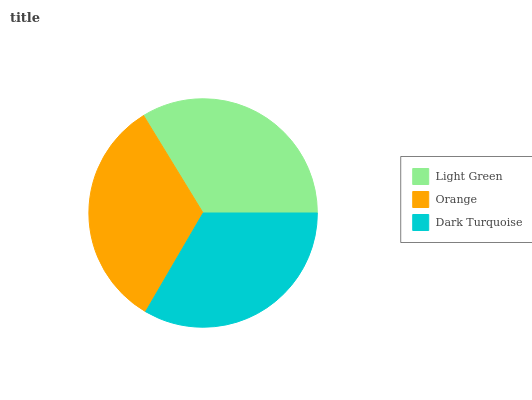Is Orange the minimum?
Answer yes or no. Yes. Is Light Green the maximum?
Answer yes or no. Yes. Is Dark Turquoise the minimum?
Answer yes or no. No. Is Dark Turquoise the maximum?
Answer yes or no. No. Is Dark Turquoise greater than Orange?
Answer yes or no. Yes. Is Orange less than Dark Turquoise?
Answer yes or no. Yes. Is Orange greater than Dark Turquoise?
Answer yes or no. No. Is Dark Turquoise less than Orange?
Answer yes or no. No. Is Dark Turquoise the high median?
Answer yes or no. Yes. Is Dark Turquoise the low median?
Answer yes or no. Yes. Is Orange the high median?
Answer yes or no. No. Is Light Green the low median?
Answer yes or no. No. 